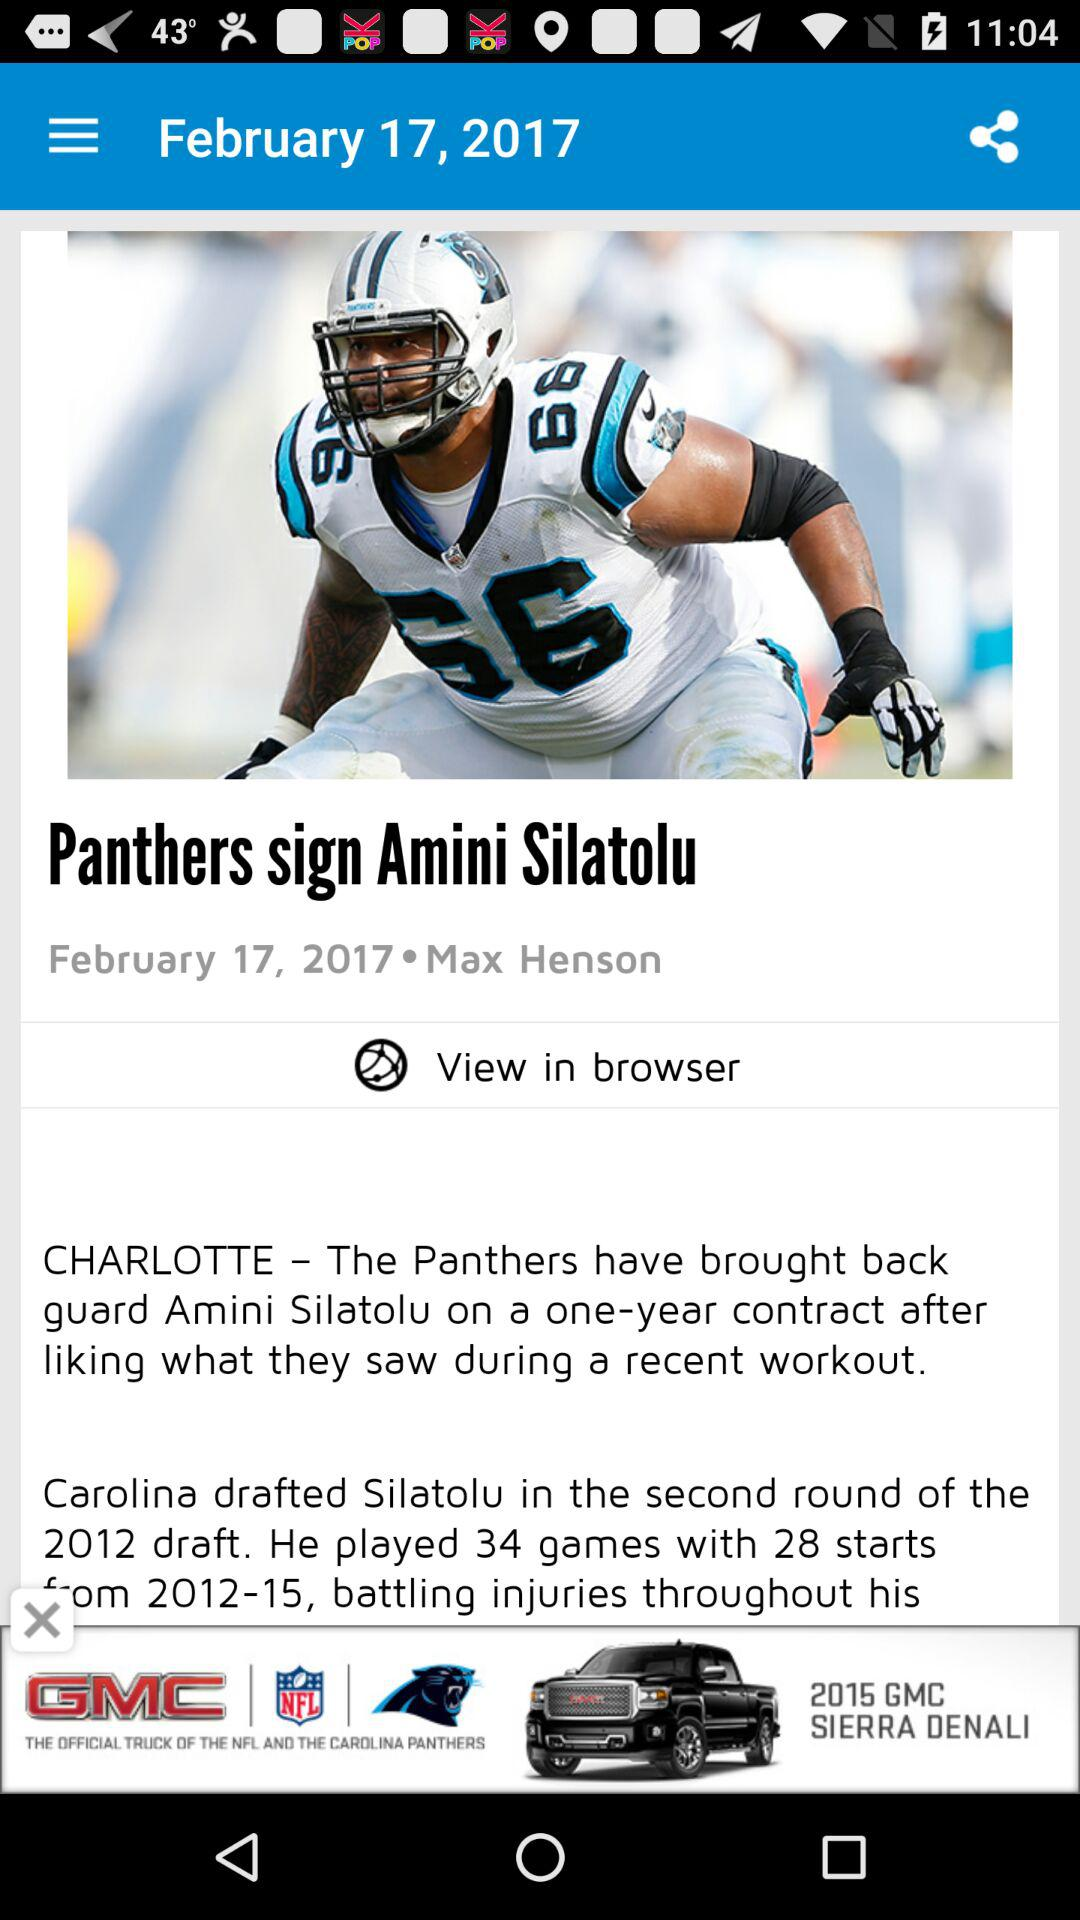How many years did Silatolu play for the Panthers?
Answer the question using a single word or phrase. 4 